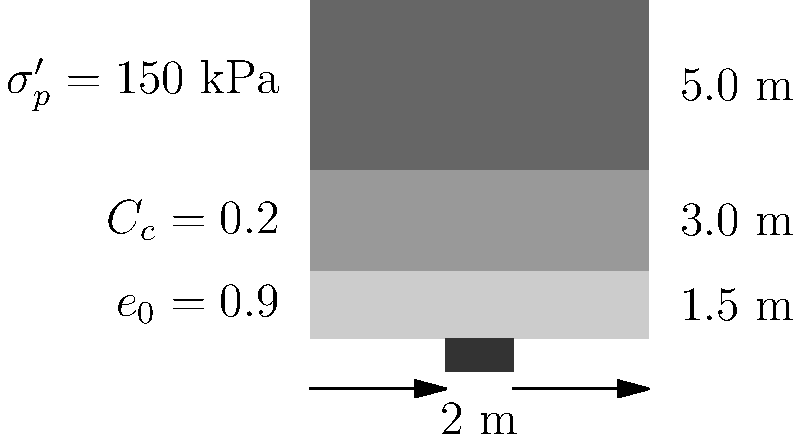A square shallow foundation (2 m x 2 m) is to be constructed on a cohesive soil profile as shown in the diagram. The soil has an initial void ratio ($e_0$) of 0.9, a compression index ($C_c$) of 0.2, and a preconsolidation pressure ($\sigma'_p$) of 150 kPa. The foundation will exert a net pressure of 100 kPa on the soil. Assuming the groundwater table is at great depth, estimate the total settlement of the foundation. To estimate the settlement of the shallow foundation, we'll follow these steps:

1) Calculate the initial effective stress ($\sigma'_0$) at the center of each layer:
   Layer 1: $\sigma'_0 = \gamma * h/2 = 18 * 1.5/2 = 13.5$ kPa
   Layer 2: $\sigma'_0 = 18 * 1.5 + 18 * 3.0/2 = 54$ kPa
   Layer 3: $\sigma'_0 = 18 * 4.5 + 18 * 5.0/2 = 126$ kPa

2) Calculate the stress increase ($\Delta \sigma$) at the center of each layer:
   Using the 2:1 method for a 2 m x 2 m foundation:
   Layer 1: $\Delta \sigma = 100 * (2*2) / (2.75*2.75) = 52.9$ kPa
   Layer 2: $\Delta \sigma = 100 * (2*2) / (5.75*5.75) = 12.1$ kPa
   Layer 3: $\Delta \sigma = 100 * (2*2) / (10.75*10.75) = 3.5$ kPa

3) Calculate the final effective stress ($\sigma'_f$) at the center of each layer:
   Layer 1: $\sigma'_f = 13.5 + 52.9 = 66.4$ kPa
   Layer 2: $\sigma'_f = 54 + 12.1 = 66.1$ kPa
   Layer 3: $\sigma'_f = 126 + 3.5 = 129.5$ kPa

4) Calculate the settlement for each layer using the compression index method:
   $$S = \frac{C_c H}{1 + e_0} \log_{10}\left(\frac{\sigma'_f}{\sigma'_0}\right)$$

   Layer 1: $S_1 = \frac{0.2 * 1.5}{1 + 0.9} \log_{10}\left(\frac{66.4}{13.5}\right) = 0.0404$ m
   Layer 2: $S_2 = \frac{0.2 * 3.0}{1 + 0.9} \log_{10}\left(\frac{66.1}{54}\right) = 0.0067$ m
   Layer 3: $S_3 = \frac{0.2 * 5.0}{1 + 0.9} \log_{10}\left(\frac{129.5}{126}\right) = 0.0006$ m

5) Sum up the settlements from all layers:
   Total Settlement = $S_1 + S_2 + S_3 = 0.0404 + 0.0067 + 0.0006 = 0.0477$ m
Answer: 0.0477 m 